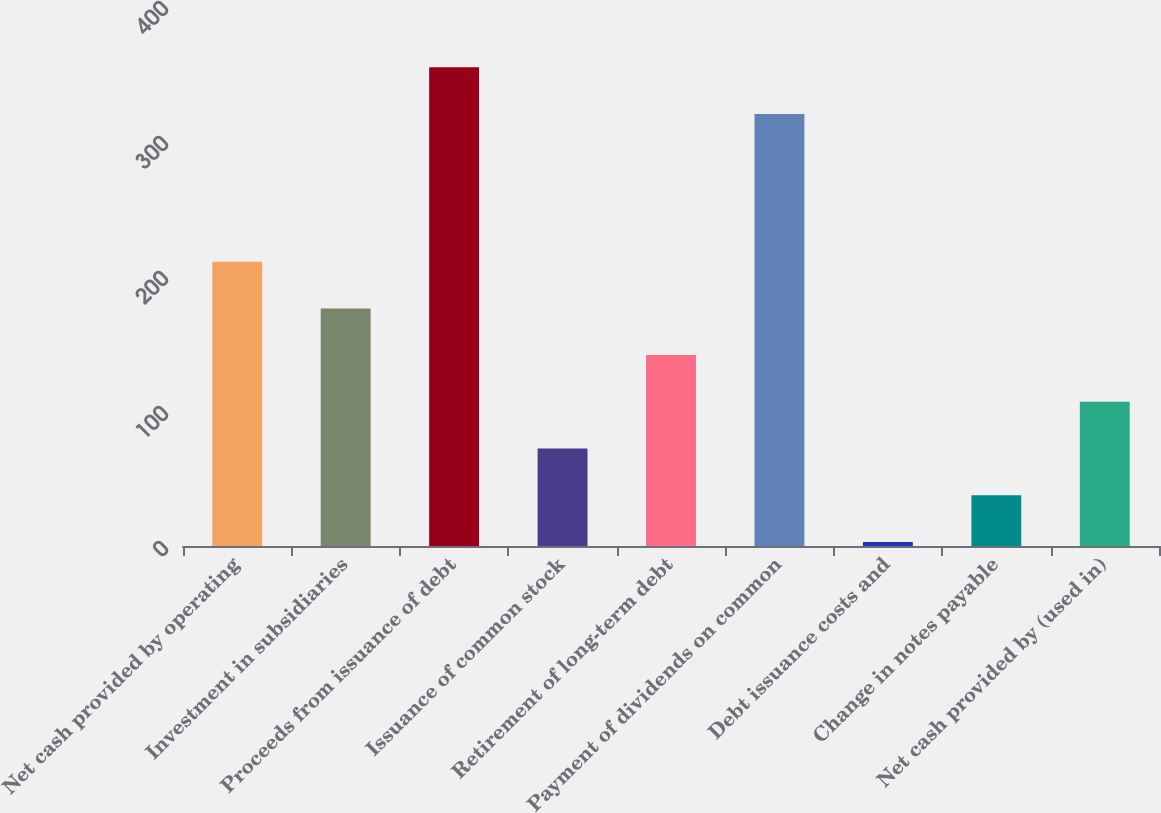Convert chart. <chart><loc_0><loc_0><loc_500><loc_500><bar_chart><fcel>Net cash provided by operating<fcel>Investment in subsidiaries<fcel>Proceeds from issuance of debt<fcel>Issuance of common stock<fcel>Retirement of long-term debt<fcel>Payment of dividends on common<fcel>Debt issuance costs and<fcel>Change in notes payable<fcel>Net cash provided by (used in)<nl><fcel>210.6<fcel>176<fcel>354.6<fcel>72.2<fcel>141.4<fcel>320<fcel>3<fcel>37.6<fcel>106.8<nl></chart> 